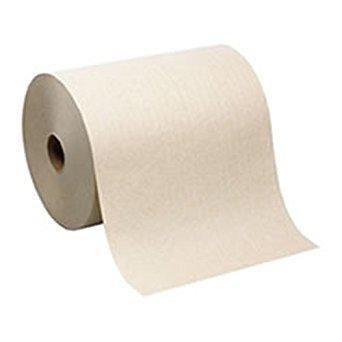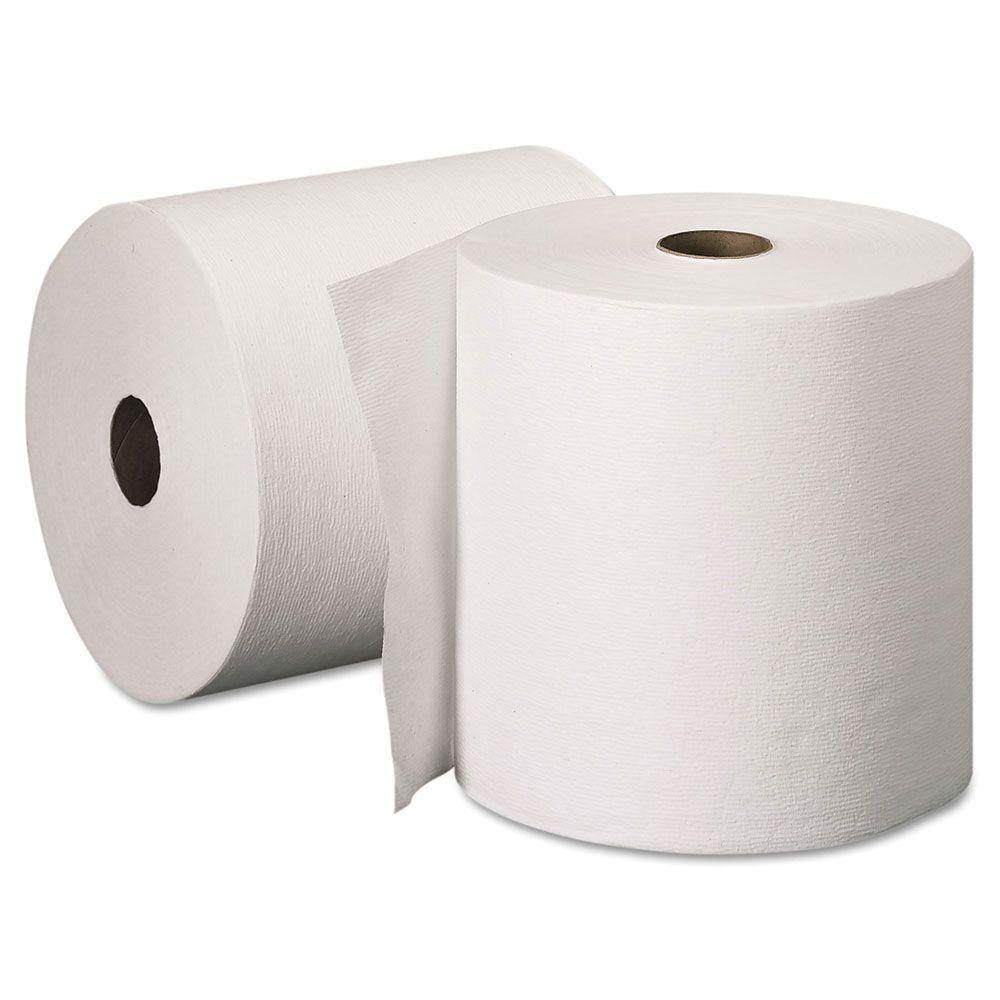The first image is the image on the left, the second image is the image on the right. Assess this claim about the two images: "The left image contains a paper towel stand.". Correct or not? Answer yes or no. No. The first image is the image on the left, the second image is the image on the right. Considering the images on both sides, is "The left and right images contain the same number of rolls." valid? Answer yes or no. No. 